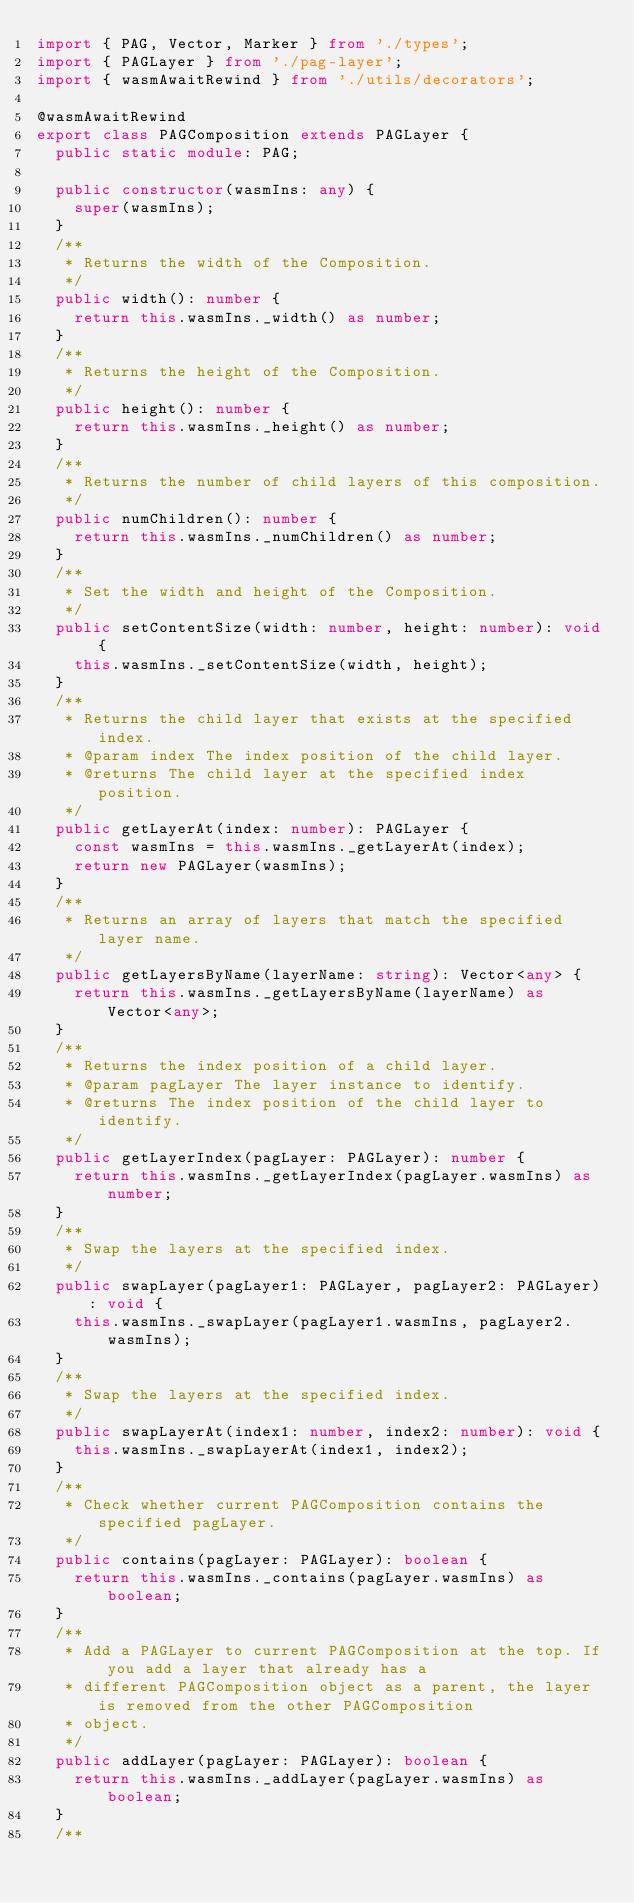<code> <loc_0><loc_0><loc_500><loc_500><_TypeScript_>import { PAG, Vector, Marker } from './types';
import { PAGLayer } from './pag-layer';
import { wasmAwaitRewind } from './utils/decorators';

@wasmAwaitRewind
export class PAGComposition extends PAGLayer {
  public static module: PAG;

  public constructor(wasmIns: any) {
    super(wasmIns);
  }
  /**
   * Returns the width of the Composition.
   */
  public width(): number {
    return this.wasmIns._width() as number;
  }
  /**
   * Returns the height of the Composition.
   */
  public height(): number {
    return this.wasmIns._height() as number;
  }
  /**
   * Returns the number of child layers of this composition.
   */
  public numChildren(): number {
    return this.wasmIns._numChildren() as number;
  }
  /**
   * Set the width and height of the Composition.
   */
  public setContentSize(width: number, height: number): void {
    this.wasmIns._setContentSize(width, height);
  }
  /**
   * Returns the child layer that exists at the specified index.
   * @param index The index position of the child layer.
   * @returns The child layer at the specified index position.
   */
  public getLayerAt(index: number): PAGLayer {
    const wasmIns = this.wasmIns._getLayerAt(index);
    return new PAGLayer(wasmIns);
  }
  /**
   * Returns an array of layers that match the specified layer name.
   */
  public getLayersByName(layerName: string): Vector<any> {
    return this.wasmIns._getLayersByName(layerName) as Vector<any>;
  }
  /**
   * Returns the index position of a child layer.
   * @param pagLayer The layer instance to identify.
   * @returns The index position of the child layer to identify.
   */
  public getLayerIndex(pagLayer: PAGLayer): number {
    return this.wasmIns._getLayerIndex(pagLayer.wasmIns) as number;
  }
  /**
   * Swap the layers at the specified index.
   */
  public swapLayer(pagLayer1: PAGLayer, pagLayer2: PAGLayer): void {
    this.wasmIns._swapLayer(pagLayer1.wasmIns, pagLayer2.wasmIns);
  }
  /**
   * Swap the layers at the specified index.
   */
  public swapLayerAt(index1: number, index2: number): void {
    this.wasmIns._swapLayerAt(index1, index2);
  }
  /**
   * Check whether current PAGComposition contains the specified pagLayer.
   */
  public contains(pagLayer: PAGLayer): boolean {
    return this.wasmIns._contains(pagLayer.wasmIns) as boolean;
  }
  /**
   * Add a PAGLayer to current PAGComposition at the top. If you add a layer that already has a
   * different PAGComposition object as a parent, the layer is removed from the other PAGComposition
   * object.
   */
  public addLayer(pagLayer: PAGLayer): boolean {
    return this.wasmIns._addLayer(pagLayer.wasmIns) as boolean;
  }
  /**</code> 